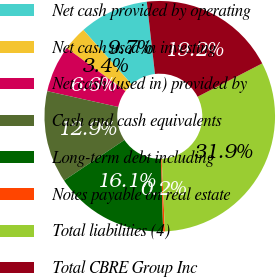<chart> <loc_0><loc_0><loc_500><loc_500><pie_chart><fcel>Net cash provided by operating<fcel>Net cash used in investing<fcel>Net cash (used in) provided by<fcel>Cash and cash equivalents<fcel>Long-term debt including<fcel>Notes payable on real estate<fcel>Total liabilities (4)<fcel>Total CBRE Group Inc<nl><fcel>9.73%<fcel>3.41%<fcel>6.57%<fcel>12.9%<fcel>16.06%<fcel>0.25%<fcel>31.86%<fcel>19.22%<nl></chart> 